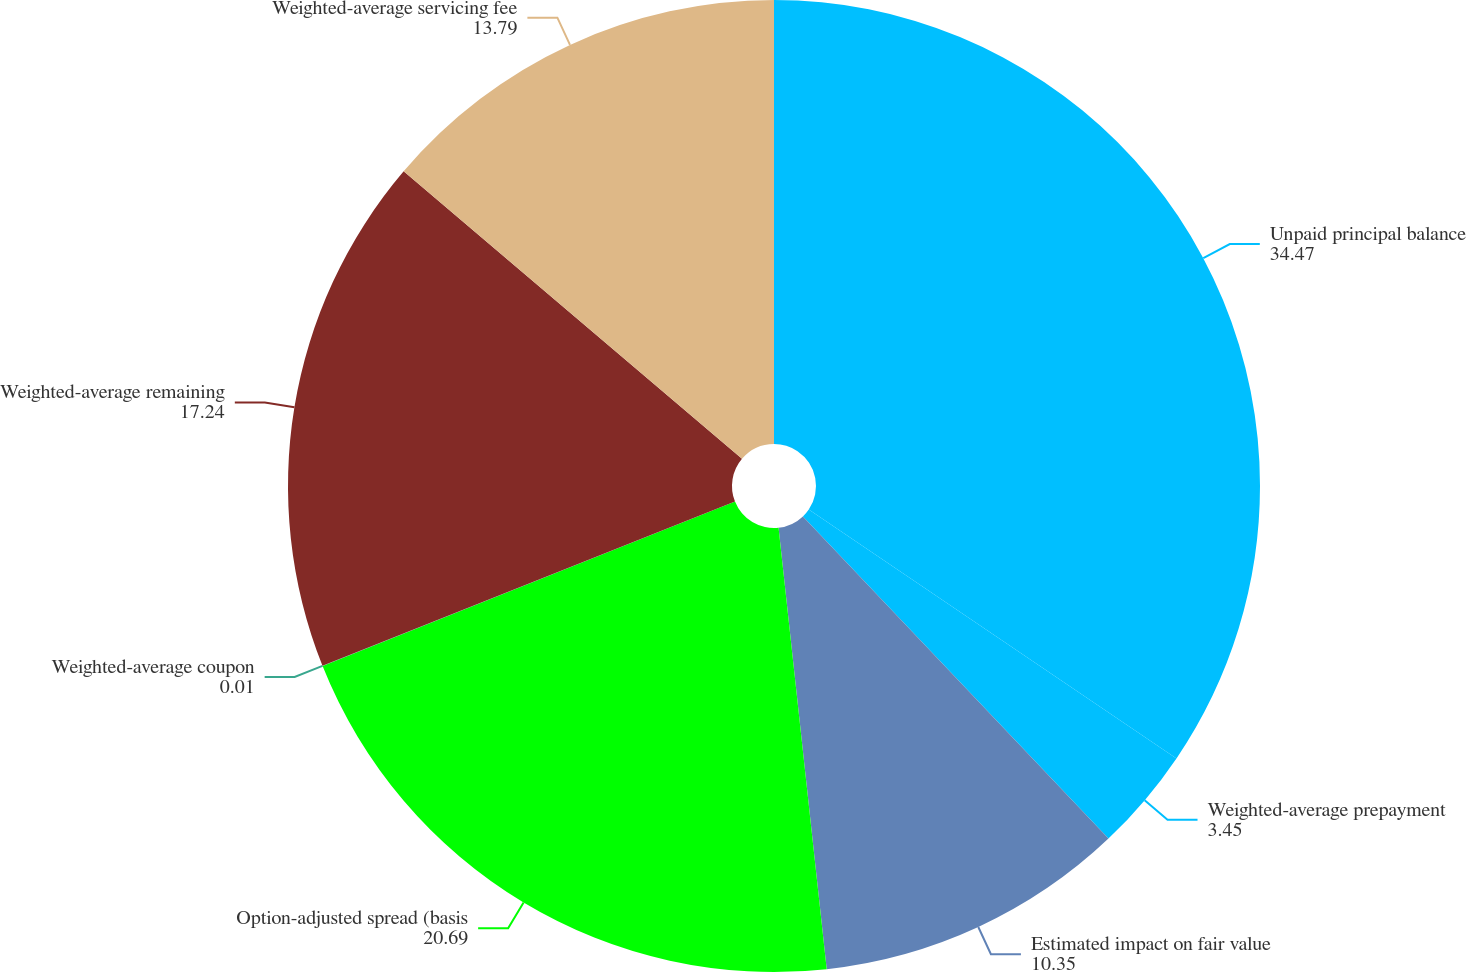Convert chart. <chart><loc_0><loc_0><loc_500><loc_500><pie_chart><fcel>Unpaid principal balance<fcel>Weighted-average prepayment<fcel>Estimated impact on fair value<fcel>Option-adjusted spread (basis<fcel>Weighted-average coupon<fcel>Weighted-average remaining<fcel>Weighted-average servicing fee<nl><fcel>34.47%<fcel>3.45%<fcel>10.35%<fcel>20.69%<fcel>0.01%<fcel>17.24%<fcel>13.79%<nl></chart> 